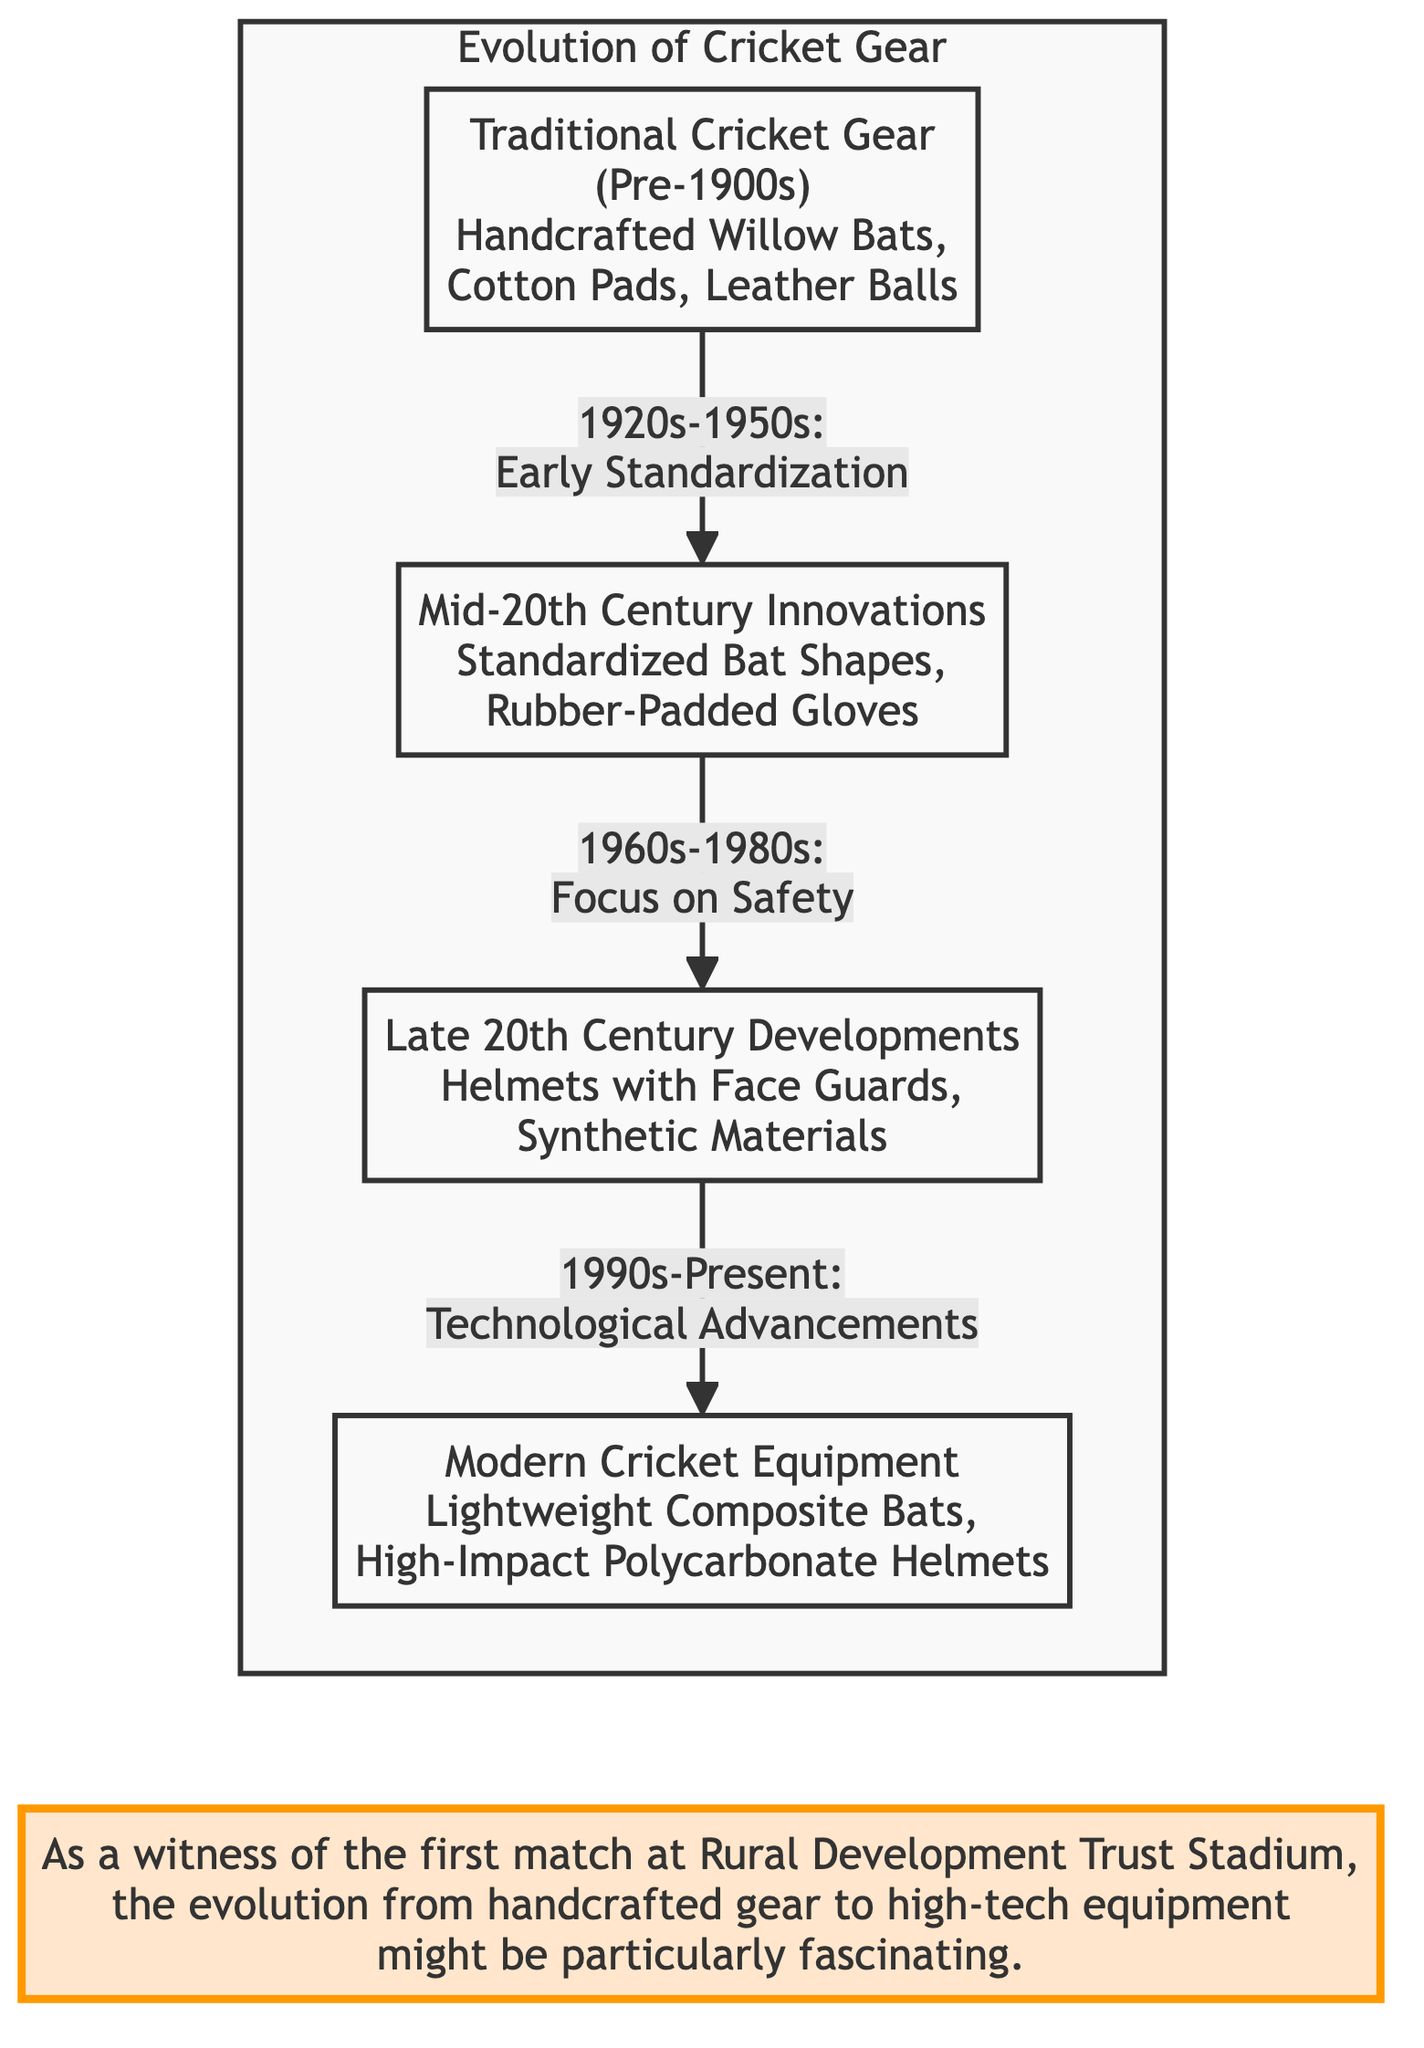What are the traditional cricket gear items listed in the diagram? The diagram highlights the traditional cricket gear as "Handcrafted Willow Bats, Cotton Pads, Leather Balls." This information is presented in the first node labeled "Traditional Cricket Gear (Pre-1900s)."
Answer: Handcrafted Willow Bats, Cotton Pads, Leather Balls Which time period is associated with the early standardization of cricket gear? The flow directed from the first node shows that early standardization corresponds to the period of the 1920s-1950s, as stated in the edge connecting nodes 1 and 2.
Answer: 1920s-1950s What is the primary focus of cricket gear development during the 1960s to 1980s? The diagram's edge from node 2 to node 3 states "Focus on Safety," indicating that this was the main concern during that time.
Answer: Focus on Safety How many distinct categories of cricket gear evolution are depicted in the diagram? By observing the diagram, there are four distinct nodes labeled: Traditional Cricket Gear, Mid-20th Century Innovations, Late 20th Century Developments, and Modern Cricket Equipment. Therefore, the total number is 4.
Answer: 4 What special features are mentioned for modern cricket equipment? The final node labeled "Modern Cricket Equipment" lists "Lightweight Composite Bats, High-Impact Polycarbonate Helmets" as significant characteristics of equipment in this category.
Answer: Lightweight Composite Bats, High-Impact Polycarbonate Helmets How does the evolution of cricket gear reflect the influence of technology from the 1990s to present? The edge leading from node 3 to node 4 states "Technological Advancements," which indicates that modern equipment's evolution incorporates such advancements that began influencing the gear from the 1990s onwards.
Answer: Technological Advancements What notable innovation was introduced in the late 20th century? The third node explains that "Helmets with Face Guards" represent a notable innovation introduced during this period, which enhances player safety.
Answer: Helmets with Face Guards What is the last node of the evolution diagram? Observing the diagram, the last node that describes the latest in cricket gear evolution is labeled "Modern Cricket Equipment," indicating the current state of cricket gear technology.
Answer: Modern Cricket Equipment What does the note indicate regarding the personal perspective on cricket gear evolution? The note highlights the perspective of witnessing the evolution from handcrafted gear to high-tech equipment, making it particularly fascinating for someone who saw the first match at the Rural Development Trust Stadium.
Answer: Witnessing the evolution 